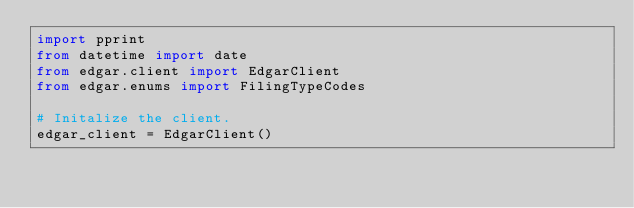Convert code to text. <code><loc_0><loc_0><loc_500><loc_500><_Python_>import pprint
from datetime import date
from edgar.client import EdgarClient
from edgar.enums import FilingTypeCodes

# Initalize the client.
edgar_client = EdgarClient()
</code> 